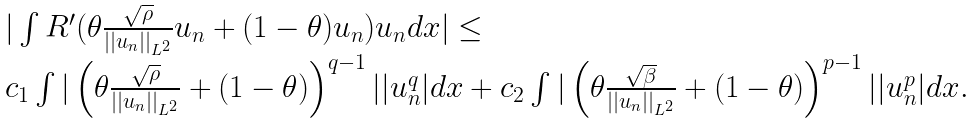Convert formula to latex. <formula><loc_0><loc_0><loc_500><loc_500>\begin{array} { l } | \int R ^ { \prime } ( \theta \frac { \sqrt { \rho } } { | | u _ { n } | | _ { L ^ { 2 } } } u _ { n } + ( 1 - \theta ) u _ { n } ) u _ { n } d x | \leq \\ c _ { 1 } \int | \left ( \theta \frac { \sqrt { \rho } } { | | u _ { n } | | _ { L ^ { 2 } } } + ( 1 - \theta ) \right ) ^ { q - 1 } | | u _ { n } ^ { q } | d x + c _ { 2 } \int | \left ( \theta \frac { \sqrt { \beta } } { | | u _ { n } | | _ { L ^ { 2 } } } + ( 1 - \theta ) \right ) ^ { p - 1 } | | u _ { n } ^ { p } | d x . \end{array}</formula> 